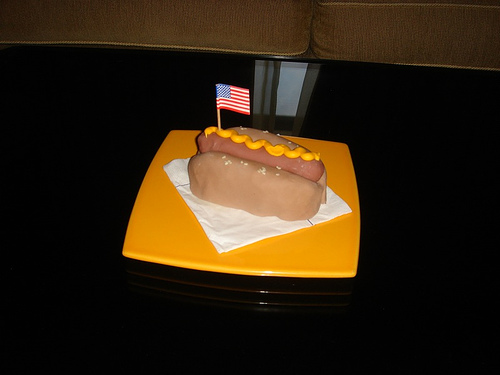What toppings are on this hotdog?
Answer the question using a single word or phrase. Mustard 